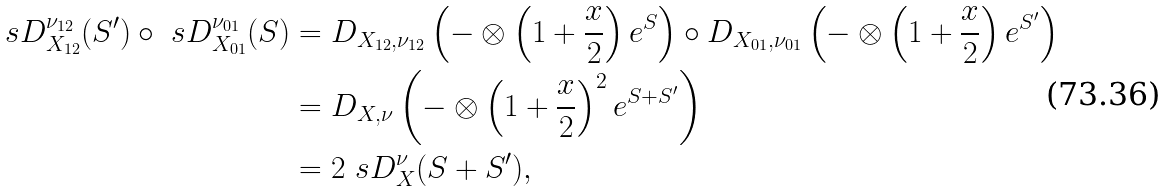<formula> <loc_0><loc_0><loc_500><loc_500>\ s D _ { X _ { 1 2 } } ^ { \nu _ { 1 2 } } ( S ^ { \prime } ) \circ \ s D _ { X _ { 0 1 } } ^ { \nu _ { 0 1 } } ( S ) & = D _ { X _ { 1 2 } , \nu _ { 1 2 } } \left ( { - } \otimes \left ( 1 + \frac { x } { 2 } \right ) e ^ { S } \right ) \circ D _ { X _ { 0 1 } , \nu _ { 0 1 } } \left ( { - } \otimes \left ( 1 + \frac { x } { 2 } \right ) e ^ { S ^ { \prime } } \right ) \\ & = D _ { X , \nu } \left ( { - } \otimes \left ( 1 + \frac { x } { 2 } \right ) ^ { 2 } e ^ { S + S ^ { \prime } } \right ) \\ & = 2 \ s D _ { X } ^ { \nu } ( S + S ^ { \prime } ) ,</formula> 